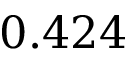Convert formula to latex. <formula><loc_0><loc_0><loc_500><loc_500>0 . 4 2 4</formula> 